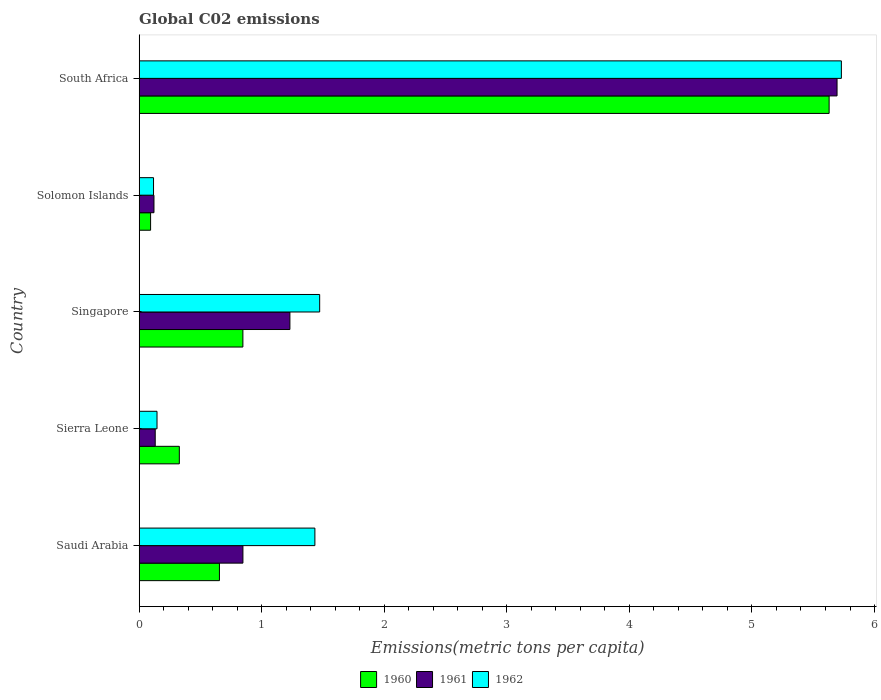How many different coloured bars are there?
Ensure brevity in your answer.  3. Are the number of bars per tick equal to the number of legend labels?
Keep it short and to the point. Yes. How many bars are there on the 4th tick from the bottom?
Offer a very short reply. 3. What is the label of the 3rd group of bars from the top?
Provide a succinct answer. Singapore. What is the amount of CO2 emitted in in 1961 in Saudi Arabia?
Offer a very short reply. 0.85. Across all countries, what is the maximum amount of CO2 emitted in in 1962?
Ensure brevity in your answer.  5.73. Across all countries, what is the minimum amount of CO2 emitted in in 1960?
Give a very brief answer. 0.09. In which country was the amount of CO2 emitted in in 1962 maximum?
Your response must be concise. South Africa. In which country was the amount of CO2 emitted in in 1960 minimum?
Make the answer very short. Solomon Islands. What is the total amount of CO2 emitted in in 1960 in the graph?
Provide a short and direct response. 7.55. What is the difference between the amount of CO2 emitted in in 1962 in Saudi Arabia and that in Sierra Leone?
Provide a short and direct response. 1.29. What is the difference between the amount of CO2 emitted in in 1962 in Sierra Leone and the amount of CO2 emitted in in 1961 in Singapore?
Give a very brief answer. -1.08. What is the average amount of CO2 emitted in in 1962 per country?
Offer a terse response. 1.78. What is the difference between the amount of CO2 emitted in in 1962 and amount of CO2 emitted in in 1961 in Singapore?
Your answer should be very brief. 0.24. In how many countries, is the amount of CO2 emitted in in 1962 greater than 2.2 metric tons per capita?
Offer a terse response. 1. What is the ratio of the amount of CO2 emitted in in 1961 in Saudi Arabia to that in Solomon Islands?
Your response must be concise. 7.01. What is the difference between the highest and the second highest amount of CO2 emitted in in 1962?
Make the answer very short. 4.26. What is the difference between the highest and the lowest amount of CO2 emitted in in 1961?
Your response must be concise. 5.57. In how many countries, is the amount of CO2 emitted in in 1961 greater than the average amount of CO2 emitted in in 1961 taken over all countries?
Make the answer very short. 1. How many bars are there?
Provide a short and direct response. 15. Does the graph contain any zero values?
Make the answer very short. No. Does the graph contain grids?
Ensure brevity in your answer.  No. Where does the legend appear in the graph?
Provide a succinct answer. Bottom center. How many legend labels are there?
Provide a short and direct response. 3. What is the title of the graph?
Your answer should be very brief. Global C02 emissions. What is the label or title of the X-axis?
Provide a short and direct response. Emissions(metric tons per capita). What is the label or title of the Y-axis?
Your answer should be compact. Country. What is the Emissions(metric tons per capita) in 1960 in Saudi Arabia?
Your answer should be very brief. 0.66. What is the Emissions(metric tons per capita) in 1961 in Saudi Arabia?
Provide a succinct answer. 0.85. What is the Emissions(metric tons per capita) of 1962 in Saudi Arabia?
Provide a short and direct response. 1.43. What is the Emissions(metric tons per capita) in 1960 in Sierra Leone?
Make the answer very short. 0.33. What is the Emissions(metric tons per capita) of 1961 in Sierra Leone?
Make the answer very short. 0.13. What is the Emissions(metric tons per capita) in 1962 in Sierra Leone?
Give a very brief answer. 0.15. What is the Emissions(metric tons per capita) in 1960 in Singapore?
Your answer should be compact. 0.85. What is the Emissions(metric tons per capita) in 1961 in Singapore?
Offer a terse response. 1.23. What is the Emissions(metric tons per capita) of 1962 in Singapore?
Make the answer very short. 1.47. What is the Emissions(metric tons per capita) in 1960 in Solomon Islands?
Offer a very short reply. 0.09. What is the Emissions(metric tons per capita) in 1961 in Solomon Islands?
Keep it short and to the point. 0.12. What is the Emissions(metric tons per capita) in 1962 in Solomon Islands?
Provide a short and direct response. 0.12. What is the Emissions(metric tons per capita) in 1960 in South Africa?
Your answer should be compact. 5.63. What is the Emissions(metric tons per capita) of 1961 in South Africa?
Provide a short and direct response. 5.69. What is the Emissions(metric tons per capita) in 1962 in South Africa?
Your answer should be compact. 5.73. Across all countries, what is the maximum Emissions(metric tons per capita) in 1960?
Give a very brief answer. 5.63. Across all countries, what is the maximum Emissions(metric tons per capita) in 1961?
Give a very brief answer. 5.69. Across all countries, what is the maximum Emissions(metric tons per capita) of 1962?
Offer a very short reply. 5.73. Across all countries, what is the minimum Emissions(metric tons per capita) in 1960?
Your answer should be compact. 0.09. Across all countries, what is the minimum Emissions(metric tons per capita) of 1961?
Your answer should be very brief. 0.12. Across all countries, what is the minimum Emissions(metric tons per capita) in 1962?
Make the answer very short. 0.12. What is the total Emissions(metric tons per capita) of 1960 in the graph?
Offer a terse response. 7.55. What is the total Emissions(metric tons per capita) in 1961 in the graph?
Provide a succinct answer. 8.02. What is the total Emissions(metric tons per capita) of 1962 in the graph?
Make the answer very short. 8.9. What is the difference between the Emissions(metric tons per capita) of 1960 in Saudi Arabia and that in Sierra Leone?
Make the answer very short. 0.33. What is the difference between the Emissions(metric tons per capita) of 1961 in Saudi Arabia and that in Sierra Leone?
Make the answer very short. 0.72. What is the difference between the Emissions(metric tons per capita) of 1962 in Saudi Arabia and that in Sierra Leone?
Keep it short and to the point. 1.29. What is the difference between the Emissions(metric tons per capita) in 1960 in Saudi Arabia and that in Singapore?
Your answer should be very brief. -0.19. What is the difference between the Emissions(metric tons per capita) of 1961 in Saudi Arabia and that in Singapore?
Offer a very short reply. -0.38. What is the difference between the Emissions(metric tons per capita) in 1962 in Saudi Arabia and that in Singapore?
Offer a very short reply. -0.04. What is the difference between the Emissions(metric tons per capita) in 1960 in Saudi Arabia and that in Solomon Islands?
Give a very brief answer. 0.56. What is the difference between the Emissions(metric tons per capita) of 1961 in Saudi Arabia and that in Solomon Islands?
Provide a succinct answer. 0.73. What is the difference between the Emissions(metric tons per capita) in 1962 in Saudi Arabia and that in Solomon Islands?
Your response must be concise. 1.32. What is the difference between the Emissions(metric tons per capita) in 1960 in Saudi Arabia and that in South Africa?
Give a very brief answer. -4.97. What is the difference between the Emissions(metric tons per capita) in 1961 in Saudi Arabia and that in South Africa?
Your response must be concise. -4.85. What is the difference between the Emissions(metric tons per capita) of 1962 in Saudi Arabia and that in South Africa?
Provide a short and direct response. -4.3. What is the difference between the Emissions(metric tons per capita) of 1960 in Sierra Leone and that in Singapore?
Offer a terse response. -0.52. What is the difference between the Emissions(metric tons per capita) of 1961 in Sierra Leone and that in Singapore?
Give a very brief answer. -1.1. What is the difference between the Emissions(metric tons per capita) of 1962 in Sierra Leone and that in Singapore?
Your response must be concise. -1.33. What is the difference between the Emissions(metric tons per capita) in 1960 in Sierra Leone and that in Solomon Islands?
Offer a terse response. 0.23. What is the difference between the Emissions(metric tons per capita) in 1961 in Sierra Leone and that in Solomon Islands?
Offer a very short reply. 0.01. What is the difference between the Emissions(metric tons per capita) in 1962 in Sierra Leone and that in Solomon Islands?
Your response must be concise. 0.03. What is the difference between the Emissions(metric tons per capita) of 1960 in Sierra Leone and that in South Africa?
Keep it short and to the point. -5.3. What is the difference between the Emissions(metric tons per capita) of 1961 in Sierra Leone and that in South Africa?
Provide a succinct answer. -5.56. What is the difference between the Emissions(metric tons per capita) of 1962 in Sierra Leone and that in South Africa?
Offer a very short reply. -5.58. What is the difference between the Emissions(metric tons per capita) of 1960 in Singapore and that in Solomon Islands?
Offer a terse response. 0.75. What is the difference between the Emissions(metric tons per capita) of 1961 in Singapore and that in Solomon Islands?
Provide a short and direct response. 1.11. What is the difference between the Emissions(metric tons per capita) of 1962 in Singapore and that in Solomon Islands?
Ensure brevity in your answer.  1.36. What is the difference between the Emissions(metric tons per capita) of 1960 in Singapore and that in South Africa?
Make the answer very short. -4.78. What is the difference between the Emissions(metric tons per capita) in 1961 in Singapore and that in South Africa?
Keep it short and to the point. -4.46. What is the difference between the Emissions(metric tons per capita) in 1962 in Singapore and that in South Africa?
Provide a short and direct response. -4.26. What is the difference between the Emissions(metric tons per capita) of 1960 in Solomon Islands and that in South Africa?
Your answer should be compact. -5.54. What is the difference between the Emissions(metric tons per capita) of 1961 in Solomon Islands and that in South Africa?
Provide a short and direct response. -5.57. What is the difference between the Emissions(metric tons per capita) in 1962 in Solomon Islands and that in South Africa?
Provide a succinct answer. -5.61. What is the difference between the Emissions(metric tons per capita) in 1960 in Saudi Arabia and the Emissions(metric tons per capita) in 1961 in Sierra Leone?
Keep it short and to the point. 0.52. What is the difference between the Emissions(metric tons per capita) in 1960 in Saudi Arabia and the Emissions(metric tons per capita) in 1962 in Sierra Leone?
Your response must be concise. 0.51. What is the difference between the Emissions(metric tons per capita) in 1961 in Saudi Arabia and the Emissions(metric tons per capita) in 1962 in Sierra Leone?
Your response must be concise. 0.7. What is the difference between the Emissions(metric tons per capita) in 1960 in Saudi Arabia and the Emissions(metric tons per capita) in 1961 in Singapore?
Offer a terse response. -0.57. What is the difference between the Emissions(metric tons per capita) in 1960 in Saudi Arabia and the Emissions(metric tons per capita) in 1962 in Singapore?
Offer a terse response. -0.82. What is the difference between the Emissions(metric tons per capita) in 1961 in Saudi Arabia and the Emissions(metric tons per capita) in 1962 in Singapore?
Your answer should be very brief. -0.63. What is the difference between the Emissions(metric tons per capita) of 1960 in Saudi Arabia and the Emissions(metric tons per capita) of 1961 in Solomon Islands?
Offer a very short reply. 0.53. What is the difference between the Emissions(metric tons per capita) in 1960 in Saudi Arabia and the Emissions(metric tons per capita) in 1962 in Solomon Islands?
Offer a very short reply. 0.54. What is the difference between the Emissions(metric tons per capita) of 1961 in Saudi Arabia and the Emissions(metric tons per capita) of 1962 in Solomon Islands?
Offer a very short reply. 0.73. What is the difference between the Emissions(metric tons per capita) in 1960 in Saudi Arabia and the Emissions(metric tons per capita) in 1961 in South Africa?
Provide a succinct answer. -5.04. What is the difference between the Emissions(metric tons per capita) of 1960 in Saudi Arabia and the Emissions(metric tons per capita) of 1962 in South Africa?
Provide a succinct answer. -5.07. What is the difference between the Emissions(metric tons per capita) in 1961 in Saudi Arabia and the Emissions(metric tons per capita) in 1962 in South Africa?
Ensure brevity in your answer.  -4.88. What is the difference between the Emissions(metric tons per capita) of 1960 in Sierra Leone and the Emissions(metric tons per capita) of 1961 in Singapore?
Ensure brevity in your answer.  -0.9. What is the difference between the Emissions(metric tons per capita) of 1960 in Sierra Leone and the Emissions(metric tons per capita) of 1962 in Singapore?
Offer a terse response. -1.15. What is the difference between the Emissions(metric tons per capita) of 1961 in Sierra Leone and the Emissions(metric tons per capita) of 1962 in Singapore?
Provide a short and direct response. -1.34. What is the difference between the Emissions(metric tons per capita) in 1960 in Sierra Leone and the Emissions(metric tons per capita) in 1961 in Solomon Islands?
Your answer should be very brief. 0.21. What is the difference between the Emissions(metric tons per capita) of 1960 in Sierra Leone and the Emissions(metric tons per capita) of 1962 in Solomon Islands?
Ensure brevity in your answer.  0.21. What is the difference between the Emissions(metric tons per capita) of 1961 in Sierra Leone and the Emissions(metric tons per capita) of 1962 in Solomon Islands?
Make the answer very short. 0.01. What is the difference between the Emissions(metric tons per capita) of 1960 in Sierra Leone and the Emissions(metric tons per capita) of 1961 in South Africa?
Offer a terse response. -5.37. What is the difference between the Emissions(metric tons per capita) of 1960 in Sierra Leone and the Emissions(metric tons per capita) of 1962 in South Africa?
Make the answer very short. -5.4. What is the difference between the Emissions(metric tons per capita) of 1961 in Sierra Leone and the Emissions(metric tons per capita) of 1962 in South Africa?
Keep it short and to the point. -5.6. What is the difference between the Emissions(metric tons per capita) of 1960 in Singapore and the Emissions(metric tons per capita) of 1961 in Solomon Islands?
Your answer should be very brief. 0.73. What is the difference between the Emissions(metric tons per capita) in 1960 in Singapore and the Emissions(metric tons per capita) in 1962 in Solomon Islands?
Your answer should be compact. 0.73. What is the difference between the Emissions(metric tons per capita) of 1961 in Singapore and the Emissions(metric tons per capita) of 1962 in Solomon Islands?
Your response must be concise. 1.11. What is the difference between the Emissions(metric tons per capita) of 1960 in Singapore and the Emissions(metric tons per capita) of 1961 in South Africa?
Provide a succinct answer. -4.85. What is the difference between the Emissions(metric tons per capita) in 1960 in Singapore and the Emissions(metric tons per capita) in 1962 in South Africa?
Give a very brief answer. -4.88. What is the difference between the Emissions(metric tons per capita) in 1961 in Singapore and the Emissions(metric tons per capita) in 1962 in South Africa?
Ensure brevity in your answer.  -4.5. What is the difference between the Emissions(metric tons per capita) in 1960 in Solomon Islands and the Emissions(metric tons per capita) in 1961 in South Africa?
Provide a succinct answer. -5.6. What is the difference between the Emissions(metric tons per capita) in 1960 in Solomon Islands and the Emissions(metric tons per capita) in 1962 in South Africa?
Keep it short and to the point. -5.64. What is the difference between the Emissions(metric tons per capita) in 1961 in Solomon Islands and the Emissions(metric tons per capita) in 1962 in South Africa?
Offer a very short reply. -5.61. What is the average Emissions(metric tons per capita) of 1960 per country?
Offer a terse response. 1.51. What is the average Emissions(metric tons per capita) in 1961 per country?
Keep it short and to the point. 1.6. What is the average Emissions(metric tons per capita) of 1962 per country?
Provide a short and direct response. 1.78. What is the difference between the Emissions(metric tons per capita) in 1960 and Emissions(metric tons per capita) in 1961 in Saudi Arabia?
Ensure brevity in your answer.  -0.19. What is the difference between the Emissions(metric tons per capita) in 1960 and Emissions(metric tons per capita) in 1962 in Saudi Arabia?
Your answer should be very brief. -0.78. What is the difference between the Emissions(metric tons per capita) of 1961 and Emissions(metric tons per capita) of 1962 in Saudi Arabia?
Offer a very short reply. -0.59. What is the difference between the Emissions(metric tons per capita) of 1960 and Emissions(metric tons per capita) of 1961 in Sierra Leone?
Offer a terse response. 0.2. What is the difference between the Emissions(metric tons per capita) in 1960 and Emissions(metric tons per capita) in 1962 in Sierra Leone?
Your answer should be very brief. 0.18. What is the difference between the Emissions(metric tons per capita) of 1961 and Emissions(metric tons per capita) of 1962 in Sierra Leone?
Make the answer very short. -0.01. What is the difference between the Emissions(metric tons per capita) of 1960 and Emissions(metric tons per capita) of 1961 in Singapore?
Make the answer very short. -0.38. What is the difference between the Emissions(metric tons per capita) of 1960 and Emissions(metric tons per capita) of 1962 in Singapore?
Your response must be concise. -0.63. What is the difference between the Emissions(metric tons per capita) in 1961 and Emissions(metric tons per capita) in 1962 in Singapore?
Give a very brief answer. -0.24. What is the difference between the Emissions(metric tons per capita) of 1960 and Emissions(metric tons per capita) of 1961 in Solomon Islands?
Ensure brevity in your answer.  -0.03. What is the difference between the Emissions(metric tons per capita) in 1960 and Emissions(metric tons per capita) in 1962 in Solomon Islands?
Your answer should be compact. -0.02. What is the difference between the Emissions(metric tons per capita) of 1961 and Emissions(metric tons per capita) of 1962 in Solomon Islands?
Offer a terse response. 0. What is the difference between the Emissions(metric tons per capita) of 1960 and Emissions(metric tons per capita) of 1961 in South Africa?
Offer a very short reply. -0.06. What is the difference between the Emissions(metric tons per capita) of 1961 and Emissions(metric tons per capita) of 1962 in South Africa?
Offer a very short reply. -0.04. What is the ratio of the Emissions(metric tons per capita) in 1960 in Saudi Arabia to that in Sierra Leone?
Provide a succinct answer. 2. What is the ratio of the Emissions(metric tons per capita) of 1961 in Saudi Arabia to that in Sierra Leone?
Keep it short and to the point. 6.46. What is the ratio of the Emissions(metric tons per capita) of 1962 in Saudi Arabia to that in Sierra Leone?
Offer a very short reply. 9.84. What is the ratio of the Emissions(metric tons per capita) in 1960 in Saudi Arabia to that in Singapore?
Provide a succinct answer. 0.77. What is the ratio of the Emissions(metric tons per capita) of 1961 in Saudi Arabia to that in Singapore?
Make the answer very short. 0.69. What is the ratio of the Emissions(metric tons per capita) in 1962 in Saudi Arabia to that in Singapore?
Your answer should be very brief. 0.97. What is the ratio of the Emissions(metric tons per capita) in 1960 in Saudi Arabia to that in Solomon Islands?
Offer a very short reply. 7.02. What is the ratio of the Emissions(metric tons per capita) in 1961 in Saudi Arabia to that in Solomon Islands?
Make the answer very short. 7.01. What is the ratio of the Emissions(metric tons per capita) in 1962 in Saudi Arabia to that in Solomon Islands?
Your answer should be very brief. 12.23. What is the ratio of the Emissions(metric tons per capita) of 1960 in Saudi Arabia to that in South Africa?
Offer a very short reply. 0.12. What is the ratio of the Emissions(metric tons per capita) in 1961 in Saudi Arabia to that in South Africa?
Provide a succinct answer. 0.15. What is the ratio of the Emissions(metric tons per capita) of 1962 in Saudi Arabia to that in South Africa?
Provide a succinct answer. 0.25. What is the ratio of the Emissions(metric tons per capita) of 1960 in Sierra Leone to that in Singapore?
Provide a succinct answer. 0.39. What is the ratio of the Emissions(metric tons per capita) of 1961 in Sierra Leone to that in Singapore?
Make the answer very short. 0.11. What is the ratio of the Emissions(metric tons per capita) in 1962 in Sierra Leone to that in Singapore?
Provide a succinct answer. 0.1. What is the ratio of the Emissions(metric tons per capita) in 1960 in Sierra Leone to that in Solomon Islands?
Ensure brevity in your answer.  3.51. What is the ratio of the Emissions(metric tons per capita) of 1961 in Sierra Leone to that in Solomon Islands?
Provide a succinct answer. 1.08. What is the ratio of the Emissions(metric tons per capita) of 1962 in Sierra Leone to that in Solomon Islands?
Offer a very short reply. 1.24. What is the ratio of the Emissions(metric tons per capita) of 1960 in Sierra Leone to that in South Africa?
Your answer should be compact. 0.06. What is the ratio of the Emissions(metric tons per capita) in 1961 in Sierra Leone to that in South Africa?
Your answer should be compact. 0.02. What is the ratio of the Emissions(metric tons per capita) in 1962 in Sierra Leone to that in South Africa?
Offer a very short reply. 0.03. What is the ratio of the Emissions(metric tons per capita) in 1960 in Singapore to that in Solomon Islands?
Ensure brevity in your answer.  9.07. What is the ratio of the Emissions(metric tons per capita) in 1961 in Singapore to that in Solomon Islands?
Make the answer very short. 10.18. What is the ratio of the Emissions(metric tons per capita) in 1962 in Singapore to that in Solomon Islands?
Give a very brief answer. 12.56. What is the ratio of the Emissions(metric tons per capita) of 1960 in Singapore to that in South Africa?
Keep it short and to the point. 0.15. What is the ratio of the Emissions(metric tons per capita) of 1961 in Singapore to that in South Africa?
Ensure brevity in your answer.  0.22. What is the ratio of the Emissions(metric tons per capita) in 1962 in Singapore to that in South Africa?
Make the answer very short. 0.26. What is the ratio of the Emissions(metric tons per capita) in 1960 in Solomon Islands to that in South Africa?
Ensure brevity in your answer.  0.02. What is the ratio of the Emissions(metric tons per capita) in 1961 in Solomon Islands to that in South Africa?
Make the answer very short. 0.02. What is the ratio of the Emissions(metric tons per capita) of 1962 in Solomon Islands to that in South Africa?
Your response must be concise. 0.02. What is the difference between the highest and the second highest Emissions(metric tons per capita) of 1960?
Offer a very short reply. 4.78. What is the difference between the highest and the second highest Emissions(metric tons per capita) in 1961?
Your answer should be very brief. 4.46. What is the difference between the highest and the second highest Emissions(metric tons per capita) in 1962?
Give a very brief answer. 4.26. What is the difference between the highest and the lowest Emissions(metric tons per capita) of 1960?
Give a very brief answer. 5.54. What is the difference between the highest and the lowest Emissions(metric tons per capita) in 1961?
Your answer should be very brief. 5.57. What is the difference between the highest and the lowest Emissions(metric tons per capita) of 1962?
Your response must be concise. 5.61. 